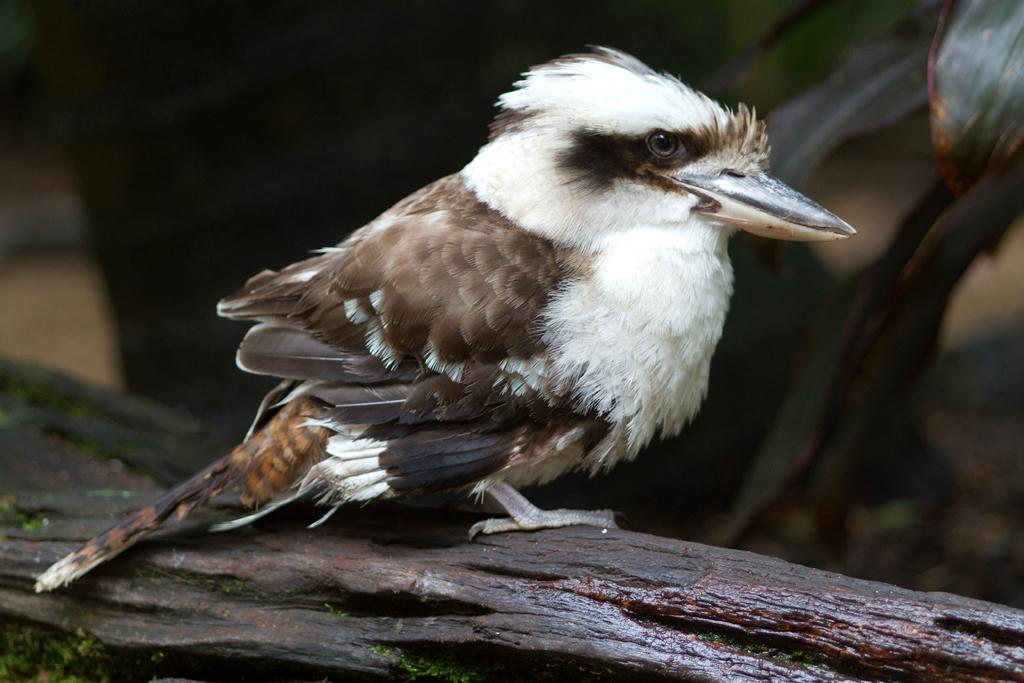What is the main subject of the picture? The main subject of the picture is a bird. Where is the bird located in the image? The bird is on the trunk of a tree. Can you describe the bird's appearance? The bird has white and brown feathers. What can be observed about the background of the image? The backdrop of the image is blurred. How many eggs can be seen in the image? There are no eggs visible in the image; it features a bird on a tree trunk. Can you describe the bird's swimming abilities in the image? The image does not show the bird swimming, so it is not possible to determine its swimming abilities. 